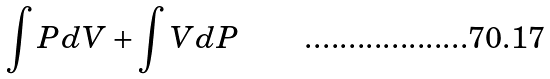Convert formula to latex. <formula><loc_0><loc_0><loc_500><loc_500>\int P d V + \int V d P</formula> 